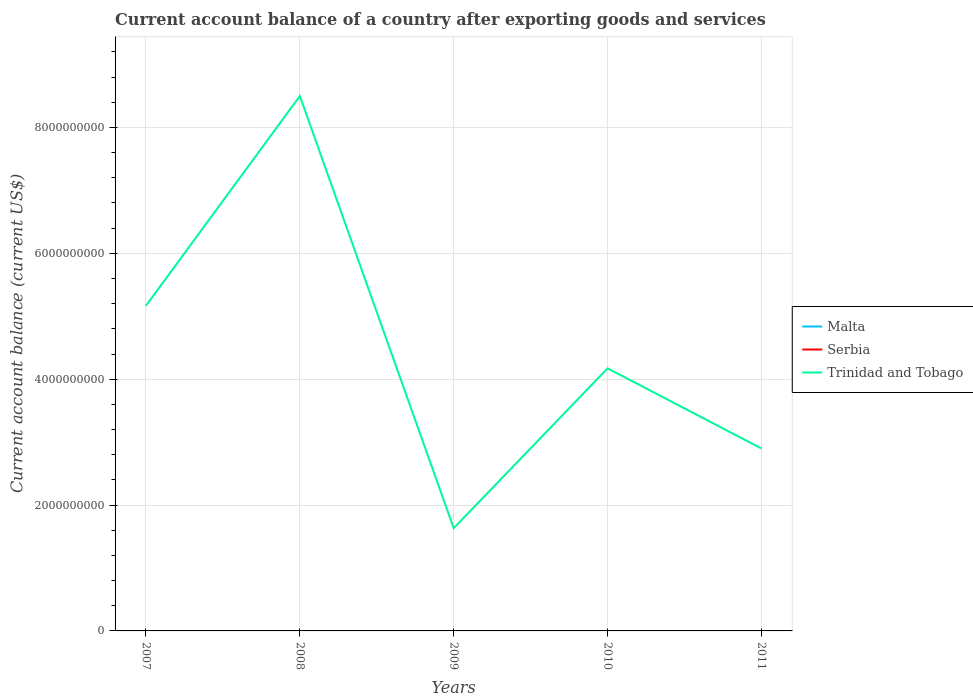How many different coloured lines are there?
Give a very brief answer. 1. Does the line corresponding to Malta intersect with the line corresponding to Serbia?
Make the answer very short. No. What is the total account balance in Trinidad and Tobago in the graph?
Make the answer very short. -2.54e+09. What is the difference between two consecutive major ticks on the Y-axis?
Provide a short and direct response. 2.00e+09. Are the values on the major ticks of Y-axis written in scientific E-notation?
Provide a succinct answer. No. Does the graph contain any zero values?
Ensure brevity in your answer.  Yes. Where does the legend appear in the graph?
Ensure brevity in your answer.  Center right. How many legend labels are there?
Make the answer very short. 3. How are the legend labels stacked?
Offer a terse response. Vertical. What is the title of the graph?
Ensure brevity in your answer.  Current account balance of a country after exporting goods and services. What is the label or title of the X-axis?
Keep it short and to the point. Years. What is the label or title of the Y-axis?
Give a very brief answer. Current account balance (current US$). What is the Current account balance (current US$) of Serbia in 2007?
Your answer should be compact. 0. What is the Current account balance (current US$) in Trinidad and Tobago in 2007?
Make the answer very short. 5.17e+09. What is the Current account balance (current US$) of Malta in 2008?
Ensure brevity in your answer.  0. What is the Current account balance (current US$) in Trinidad and Tobago in 2008?
Give a very brief answer. 8.50e+09. What is the Current account balance (current US$) in Malta in 2009?
Make the answer very short. 0. What is the Current account balance (current US$) of Serbia in 2009?
Provide a succinct answer. 0. What is the Current account balance (current US$) in Trinidad and Tobago in 2009?
Offer a terse response. 1.63e+09. What is the Current account balance (current US$) of Trinidad and Tobago in 2010?
Provide a succinct answer. 4.17e+09. What is the Current account balance (current US$) of Malta in 2011?
Offer a very short reply. 0. What is the Current account balance (current US$) in Trinidad and Tobago in 2011?
Your response must be concise. 2.90e+09. Across all years, what is the maximum Current account balance (current US$) in Trinidad and Tobago?
Ensure brevity in your answer.  8.50e+09. Across all years, what is the minimum Current account balance (current US$) in Trinidad and Tobago?
Provide a short and direct response. 1.63e+09. What is the total Current account balance (current US$) in Trinidad and Tobago in the graph?
Give a very brief answer. 2.24e+1. What is the difference between the Current account balance (current US$) of Trinidad and Tobago in 2007 and that in 2008?
Make the answer very short. -3.33e+09. What is the difference between the Current account balance (current US$) in Trinidad and Tobago in 2007 and that in 2009?
Offer a very short reply. 3.53e+09. What is the difference between the Current account balance (current US$) in Trinidad and Tobago in 2007 and that in 2010?
Your answer should be very brief. 9.94e+08. What is the difference between the Current account balance (current US$) of Trinidad and Tobago in 2007 and that in 2011?
Make the answer very short. 2.27e+09. What is the difference between the Current account balance (current US$) of Trinidad and Tobago in 2008 and that in 2009?
Provide a succinct answer. 6.87e+09. What is the difference between the Current account balance (current US$) of Trinidad and Tobago in 2008 and that in 2010?
Offer a terse response. 4.33e+09. What is the difference between the Current account balance (current US$) of Trinidad and Tobago in 2008 and that in 2011?
Provide a short and direct response. 5.60e+09. What is the difference between the Current account balance (current US$) in Trinidad and Tobago in 2009 and that in 2010?
Keep it short and to the point. -2.54e+09. What is the difference between the Current account balance (current US$) in Trinidad and Tobago in 2009 and that in 2011?
Provide a succinct answer. -1.27e+09. What is the difference between the Current account balance (current US$) in Trinidad and Tobago in 2010 and that in 2011?
Your answer should be compact. 1.27e+09. What is the average Current account balance (current US$) of Trinidad and Tobago per year?
Give a very brief answer. 4.47e+09. What is the ratio of the Current account balance (current US$) of Trinidad and Tobago in 2007 to that in 2008?
Offer a terse response. 0.61. What is the ratio of the Current account balance (current US$) in Trinidad and Tobago in 2007 to that in 2009?
Provide a succinct answer. 3.16. What is the ratio of the Current account balance (current US$) in Trinidad and Tobago in 2007 to that in 2010?
Your answer should be compact. 1.24. What is the ratio of the Current account balance (current US$) of Trinidad and Tobago in 2007 to that in 2011?
Provide a short and direct response. 1.78. What is the ratio of the Current account balance (current US$) in Trinidad and Tobago in 2008 to that in 2009?
Provide a succinct answer. 5.21. What is the ratio of the Current account balance (current US$) of Trinidad and Tobago in 2008 to that in 2010?
Provide a succinct answer. 2.04. What is the ratio of the Current account balance (current US$) of Trinidad and Tobago in 2008 to that in 2011?
Keep it short and to the point. 2.93. What is the ratio of the Current account balance (current US$) in Trinidad and Tobago in 2009 to that in 2010?
Offer a very short reply. 0.39. What is the ratio of the Current account balance (current US$) in Trinidad and Tobago in 2009 to that in 2011?
Offer a terse response. 0.56. What is the ratio of the Current account balance (current US$) in Trinidad and Tobago in 2010 to that in 2011?
Provide a succinct answer. 1.44. What is the difference between the highest and the second highest Current account balance (current US$) of Trinidad and Tobago?
Your response must be concise. 3.33e+09. What is the difference between the highest and the lowest Current account balance (current US$) of Trinidad and Tobago?
Keep it short and to the point. 6.87e+09. 